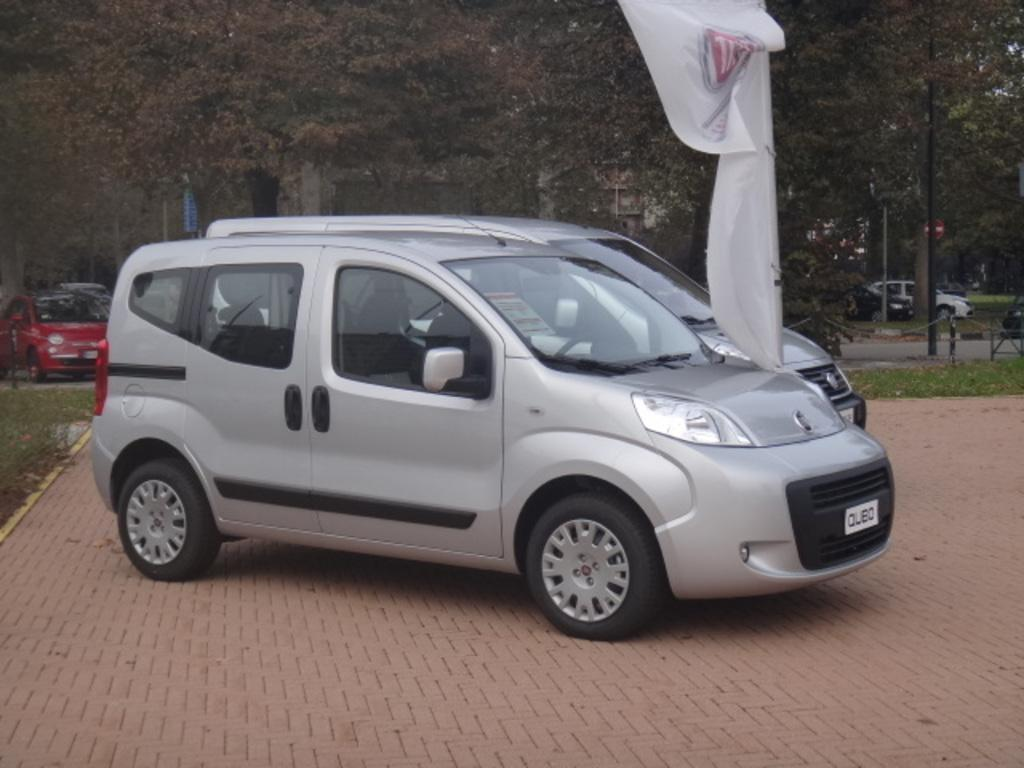How many cars are parked in the image? There are two cars parked in the image. What is the color or type of the flag visible in the image? There is a white flag visible in the image. What is happening with the cars in the background of the image? Cars are moving on the background of the image. What type of natural scenery can be seen in the background of the image? There are trees in the background of the image. What type of man-made structures can be seen in the background of the image? There are buildings in the background of the image. What type of crayon is the kitten using to draw a scent in the image? There is no kitten, crayon, or scent present in the image. 